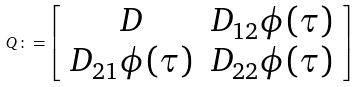<formula> <loc_0><loc_0><loc_500><loc_500>Q \colon = \left [ \begin{array} { c c } D & D _ { 1 2 } \phi ( \tau ) \\ D _ { 2 1 } \phi ( \tau ) & D _ { 2 2 } \phi ( \tau ) \end{array} \right ]</formula> 